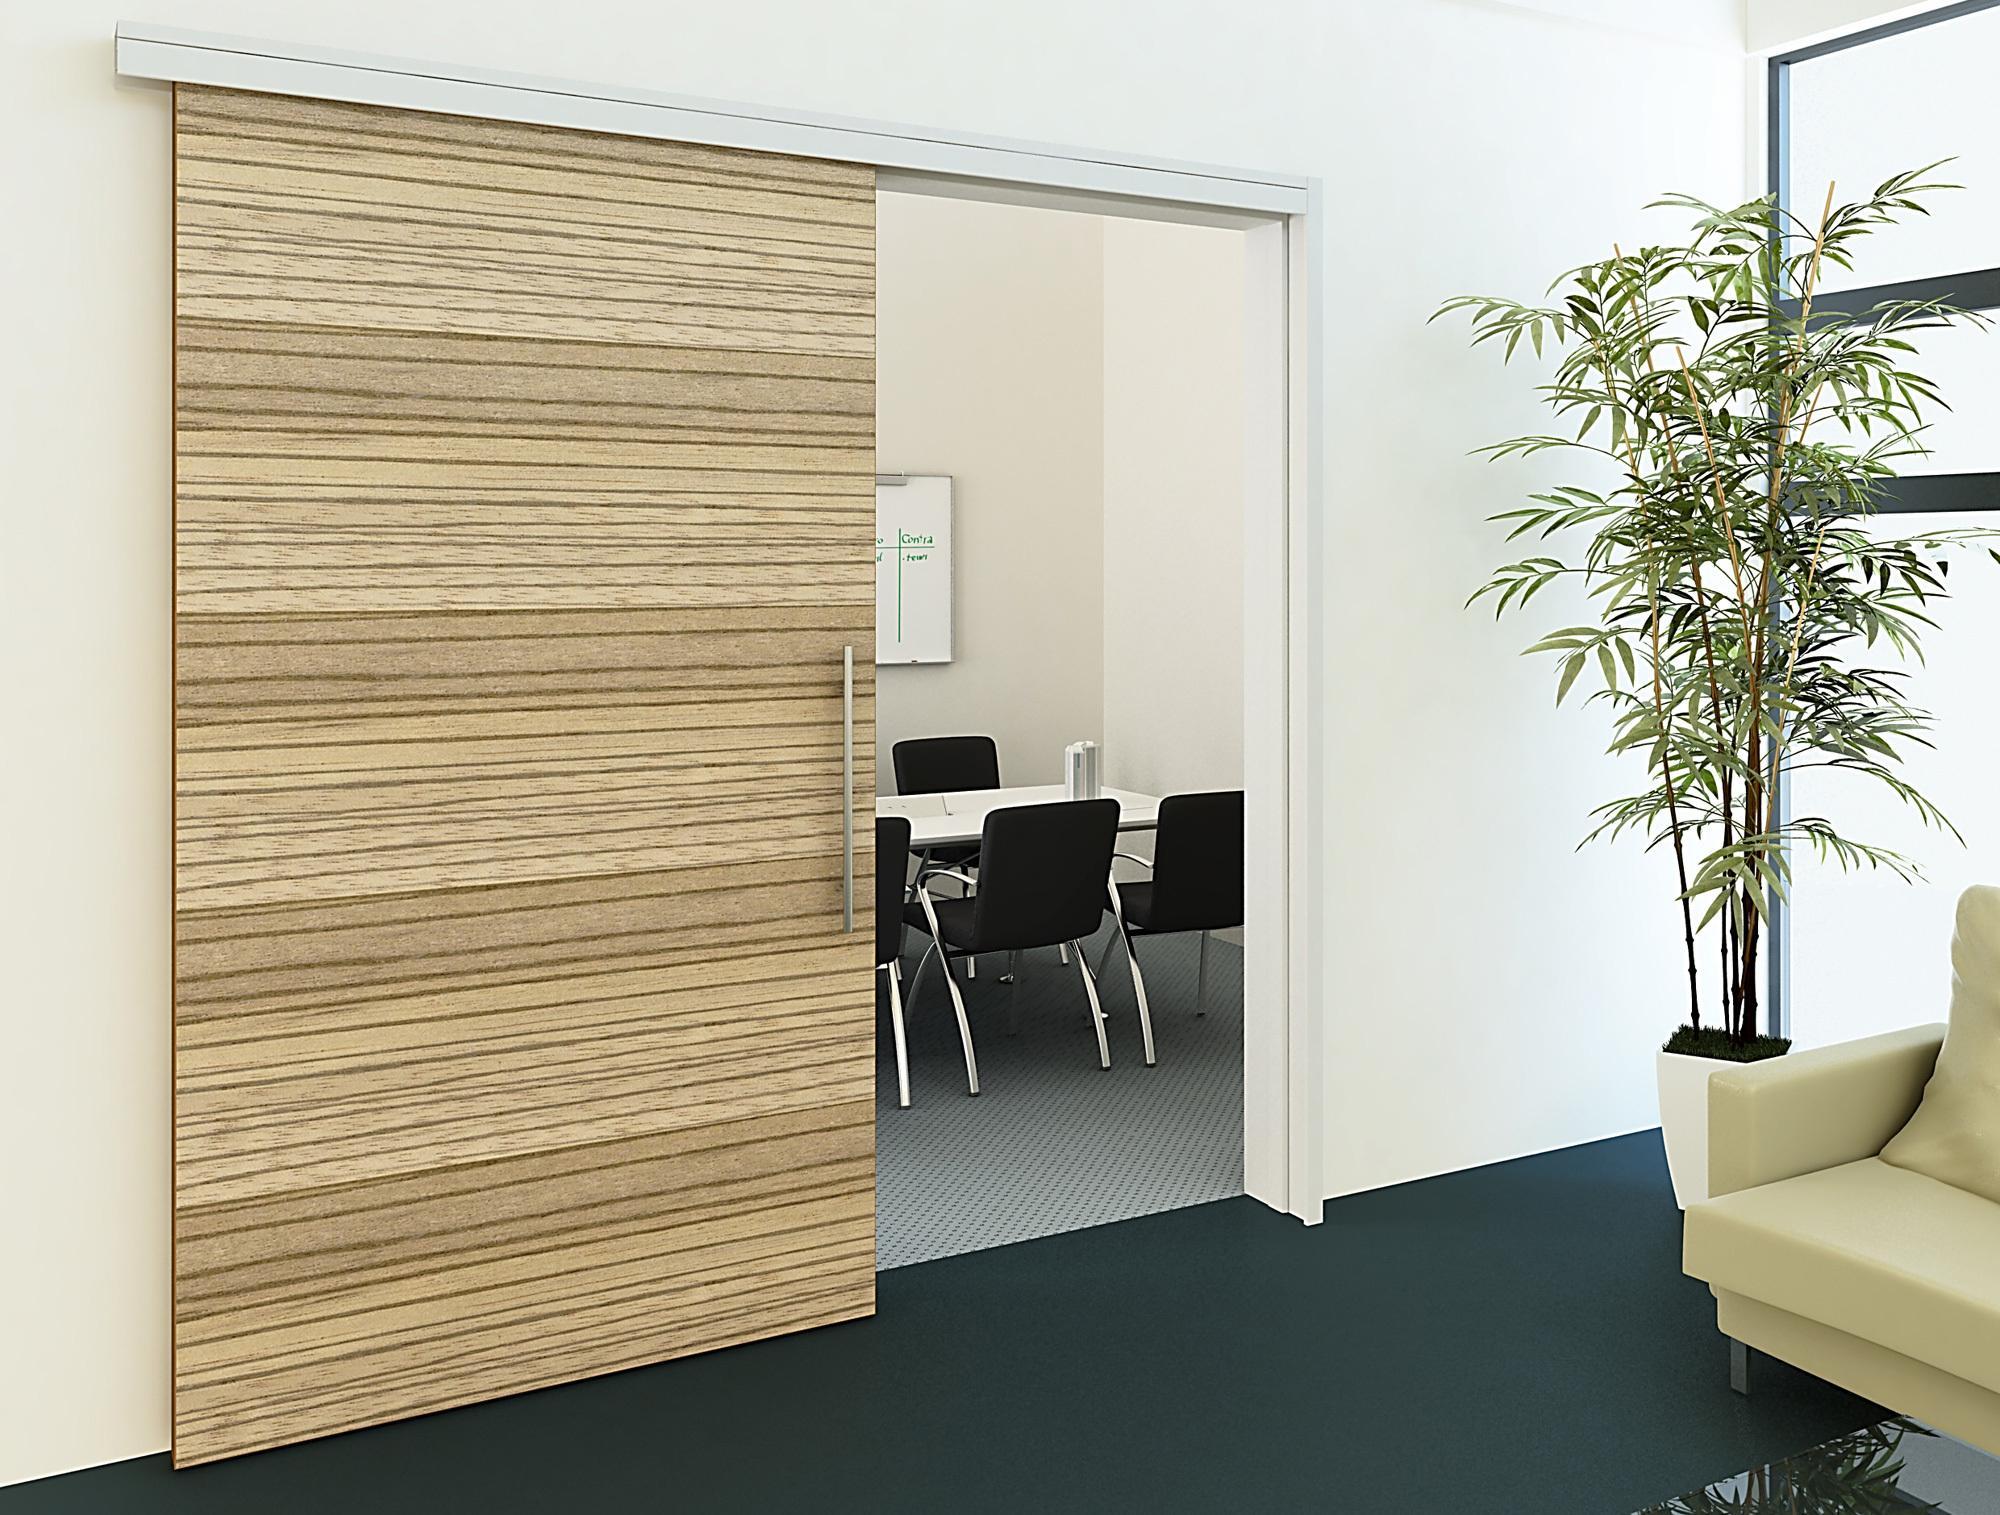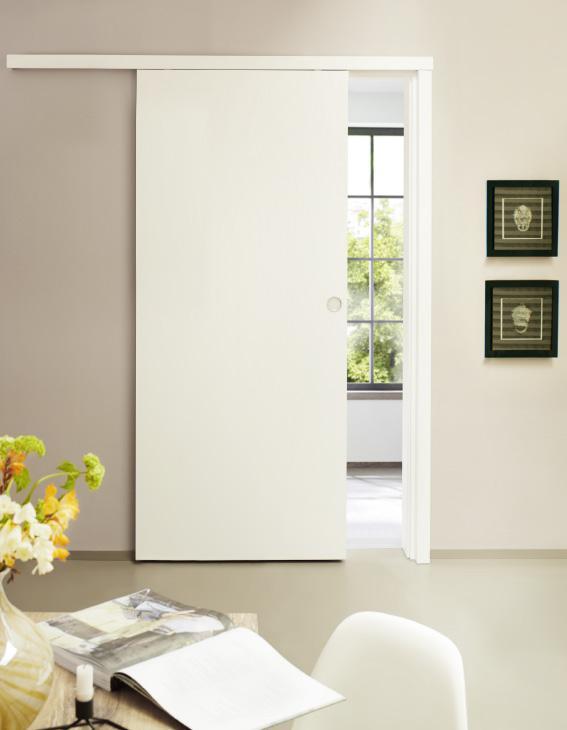The first image is the image on the left, the second image is the image on the right. Assess this claim about the two images: "One door is glass.". Correct or not? Answer yes or no. No. 